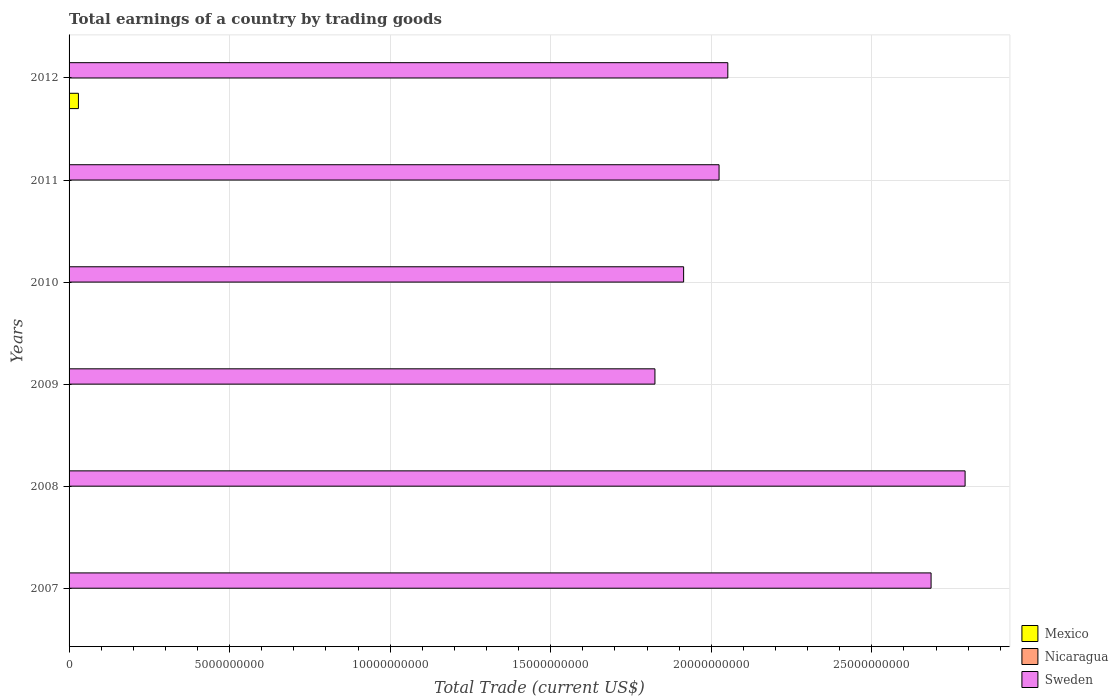How many different coloured bars are there?
Your response must be concise. 2. Are the number of bars on each tick of the Y-axis equal?
Make the answer very short. No. How many bars are there on the 2nd tick from the top?
Your response must be concise. 1. Across all years, what is the maximum total earnings in Sweden?
Offer a terse response. 2.79e+1. Across all years, what is the minimum total earnings in Sweden?
Give a very brief answer. 1.82e+1. In which year was the total earnings in Mexico maximum?
Provide a short and direct response. 2012. What is the total total earnings in Sweden in the graph?
Keep it short and to the point. 1.33e+11. What is the difference between the total earnings in Sweden in 2008 and that in 2010?
Make the answer very short. 8.77e+09. What is the difference between the total earnings in Nicaragua in 2007 and the total earnings in Sweden in 2012?
Ensure brevity in your answer.  -2.05e+1. What is the average total earnings in Mexico per year?
Make the answer very short. 4.85e+07. In the year 2012, what is the difference between the total earnings in Mexico and total earnings in Sweden?
Your answer should be very brief. -2.02e+1. In how many years, is the total earnings in Nicaragua greater than 2000000000 US$?
Offer a terse response. 0. What is the ratio of the total earnings in Sweden in 2010 to that in 2011?
Your answer should be very brief. 0.95. What is the difference between the highest and the second highest total earnings in Sweden?
Your response must be concise. 1.06e+09. What is the difference between the highest and the lowest total earnings in Sweden?
Make the answer very short. 9.66e+09. Is the sum of the total earnings in Sweden in 2009 and 2010 greater than the maximum total earnings in Mexico across all years?
Your answer should be compact. Yes. Are all the bars in the graph horizontal?
Provide a short and direct response. Yes. How many years are there in the graph?
Make the answer very short. 6. Does the graph contain any zero values?
Keep it short and to the point. Yes. How many legend labels are there?
Offer a very short reply. 3. How are the legend labels stacked?
Ensure brevity in your answer.  Vertical. What is the title of the graph?
Your response must be concise. Total earnings of a country by trading goods. What is the label or title of the X-axis?
Give a very brief answer. Total Trade (current US$). What is the label or title of the Y-axis?
Give a very brief answer. Years. What is the Total Trade (current US$) in Nicaragua in 2007?
Make the answer very short. 0. What is the Total Trade (current US$) in Sweden in 2007?
Provide a succinct answer. 2.68e+1. What is the Total Trade (current US$) of Mexico in 2008?
Your response must be concise. 0. What is the Total Trade (current US$) of Sweden in 2008?
Ensure brevity in your answer.  2.79e+1. What is the Total Trade (current US$) in Mexico in 2009?
Your response must be concise. 0. What is the Total Trade (current US$) of Nicaragua in 2009?
Offer a terse response. 0. What is the Total Trade (current US$) in Sweden in 2009?
Your answer should be compact. 1.82e+1. What is the Total Trade (current US$) of Sweden in 2010?
Provide a succinct answer. 1.91e+1. What is the Total Trade (current US$) in Sweden in 2011?
Offer a terse response. 2.02e+1. What is the Total Trade (current US$) in Mexico in 2012?
Ensure brevity in your answer.  2.91e+08. What is the Total Trade (current US$) of Sweden in 2012?
Offer a terse response. 2.05e+1. Across all years, what is the maximum Total Trade (current US$) of Mexico?
Provide a succinct answer. 2.91e+08. Across all years, what is the maximum Total Trade (current US$) in Sweden?
Keep it short and to the point. 2.79e+1. Across all years, what is the minimum Total Trade (current US$) in Mexico?
Offer a very short reply. 0. Across all years, what is the minimum Total Trade (current US$) of Sweden?
Give a very brief answer. 1.82e+1. What is the total Total Trade (current US$) of Mexico in the graph?
Provide a short and direct response. 2.91e+08. What is the total Total Trade (current US$) of Nicaragua in the graph?
Keep it short and to the point. 0. What is the total Total Trade (current US$) in Sweden in the graph?
Your response must be concise. 1.33e+11. What is the difference between the Total Trade (current US$) in Sweden in 2007 and that in 2008?
Your response must be concise. -1.06e+09. What is the difference between the Total Trade (current US$) of Sweden in 2007 and that in 2009?
Keep it short and to the point. 8.60e+09. What is the difference between the Total Trade (current US$) in Sweden in 2007 and that in 2010?
Ensure brevity in your answer.  7.71e+09. What is the difference between the Total Trade (current US$) in Sweden in 2007 and that in 2011?
Your answer should be compact. 6.60e+09. What is the difference between the Total Trade (current US$) of Sweden in 2007 and that in 2012?
Your answer should be compact. 6.33e+09. What is the difference between the Total Trade (current US$) in Sweden in 2008 and that in 2009?
Offer a terse response. 9.66e+09. What is the difference between the Total Trade (current US$) of Sweden in 2008 and that in 2010?
Provide a short and direct response. 8.77e+09. What is the difference between the Total Trade (current US$) of Sweden in 2008 and that in 2011?
Your answer should be compact. 7.66e+09. What is the difference between the Total Trade (current US$) of Sweden in 2008 and that in 2012?
Ensure brevity in your answer.  7.39e+09. What is the difference between the Total Trade (current US$) of Sweden in 2009 and that in 2010?
Provide a short and direct response. -8.94e+08. What is the difference between the Total Trade (current US$) of Sweden in 2009 and that in 2011?
Ensure brevity in your answer.  -2.00e+09. What is the difference between the Total Trade (current US$) in Sweden in 2009 and that in 2012?
Ensure brevity in your answer.  -2.27e+09. What is the difference between the Total Trade (current US$) of Sweden in 2010 and that in 2011?
Your answer should be very brief. -1.10e+09. What is the difference between the Total Trade (current US$) in Sweden in 2010 and that in 2012?
Provide a short and direct response. -1.38e+09. What is the difference between the Total Trade (current US$) of Sweden in 2011 and that in 2012?
Provide a short and direct response. -2.72e+08. What is the average Total Trade (current US$) in Mexico per year?
Give a very brief answer. 4.85e+07. What is the average Total Trade (current US$) in Nicaragua per year?
Provide a short and direct response. 0. What is the average Total Trade (current US$) of Sweden per year?
Offer a very short reply. 2.21e+1. In the year 2012, what is the difference between the Total Trade (current US$) of Mexico and Total Trade (current US$) of Sweden?
Provide a short and direct response. -2.02e+1. What is the ratio of the Total Trade (current US$) in Sweden in 2007 to that in 2008?
Make the answer very short. 0.96. What is the ratio of the Total Trade (current US$) of Sweden in 2007 to that in 2009?
Ensure brevity in your answer.  1.47. What is the ratio of the Total Trade (current US$) in Sweden in 2007 to that in 2010?
Offer a very short reply. 1.4. What is the ratio of the Total Trade (current US$) of Sweden in 2007 to that in 2011?
Your response must be concise. 1.33. What is the ratio of the Total Trade (current US$) of Sweden in 2007 to that in 2012?
Give a very brief answer. 1.31. What is the ratio of the Total Trade (current US$) of Sweden in 2008 to that in 2009?
Ensure brevity in your answer.  1.53. What is the ratio of the Total Trade (current US$) in Sweden in 2008 to that in 2010?
Your answer should be compact. 1.46. What is the ratio of the Total Trade (current US$) of Sweden in 2008 to that in 2011?
Offer a very short reply. 1.38. What is the ratio of the Total Trade (current US$) in Sweden in 2008 to that in 2012?
Provide a succinct answer. 1.36. What is the ratio of the Total Trade (current US$) in Sweden in 2009 to that in 2010?
Give a very brief answer. 0.95. What is the ratio of the Total Trade (current US$) in Sweden in 2009 to that in 2011?
Your answer should be very brief. 0.9. What is the ratio of the Total Trade (current US$) of Sweden in 2009 to that in 2012?
Offer a very short reply. 0.89. What is the ratio of the Total Trade (current US$) in Sweden in 2010 to that in 2011?
Provide a short and direct response. 0.95. What is the ratio of the Total Trade (current US$) of Sweden in 2010 to that in 2012?
Provide a succinct answer. 0.93. What is the ratio of the Total Trade (current US$) of Sweden in 2011 to that in 2012?
Ensure brevity in your answer.  0.99. What is the difference between the highest and the second highest Total Trade (current US$) in Sweden?
Provide a short and direct response. 1.06e+09. What is the difference between the highest and the lowest Total Trade (current US$) of Mexico?
Provide a succinct answer. 2.91e+08. What is the difference between the highest and the lowest Total Trade (current US$) in Sweden?
Provide a short and direct response. 9.66e+09. 